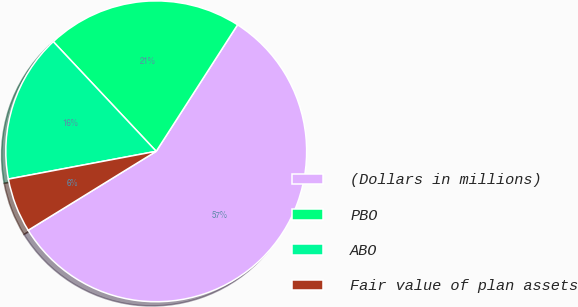Convert chart. <chart><loc_0><loc_0><loc_500><loc_500><pie_chart><fcel>(Dollars in millions)<fcel>PBO<fcel>ABO<fcel>Fair value of plan assets<nl><fcel>57.11%<fcel>21.09%<fcel>15.96%<fcel>5.84%<nl></chart> 